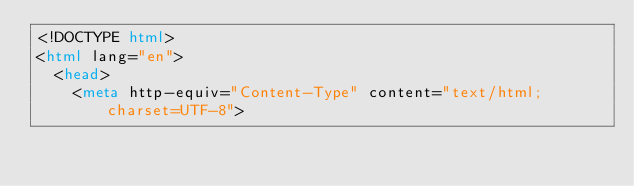Convert code to text. <code><loc_0><loc_0><loc_500><loc_500><_HTML_><!DOCTYPE html>
<html lang="en">
  <head>
    <meta http-equiv="Content-Type" content="text/html; charset=UTF-8"></code> 